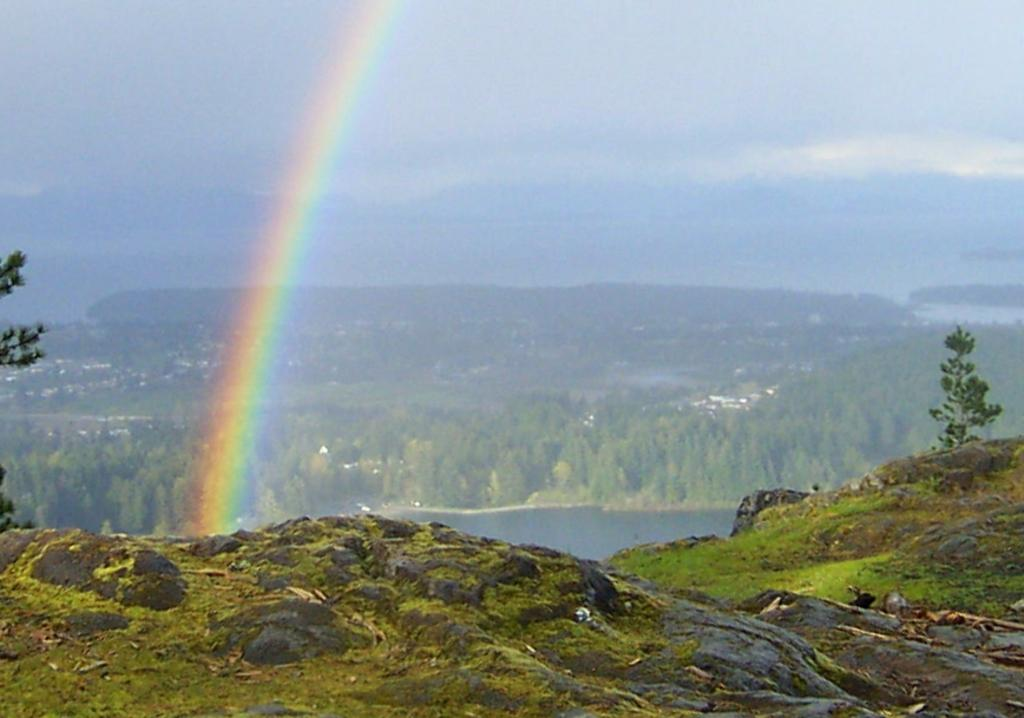What natural phenomenon can be seen in the image? There is a rainbow in the image. What is the primary source of the rainbow in the image? The rainbow is formed due to the presence of water visible in the image. What type of vegetation is visible in the background of the image? There are trees in the background of the image. What is visible at the top of the image? The sky is visible at the top of the image. What type of bells can be heard ringing in the image? There are no bells present in the image, and therefore no sound can be heard. How is the match used in the image? There is no match present in the image. 